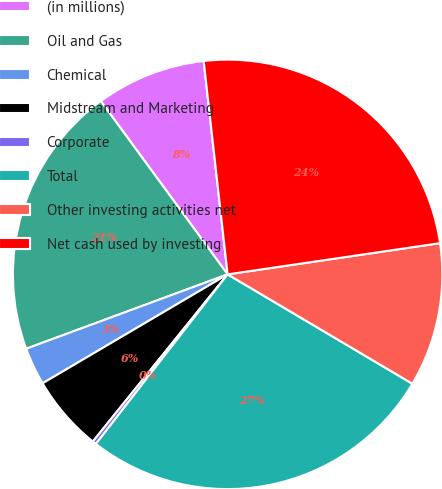<chart> <loc_0><loc_0><loc_500><loc_500><pie_chart><fcel>(in millions)<fcel>Oil and Gas<fcel>Chemical<fcel>Midstream and Marketing<fcel>Corporate<fcel>Total<fcel>Other investing activities net<fcel>Net cash used by investing<nl><fcel>8.28%<fcel>20.58%<fcel>2.84%<fcel>5.73%<fcel>0.29%<fcel>27.01%<fcel>10.83%<fcel>24.46%<nl></chart> 